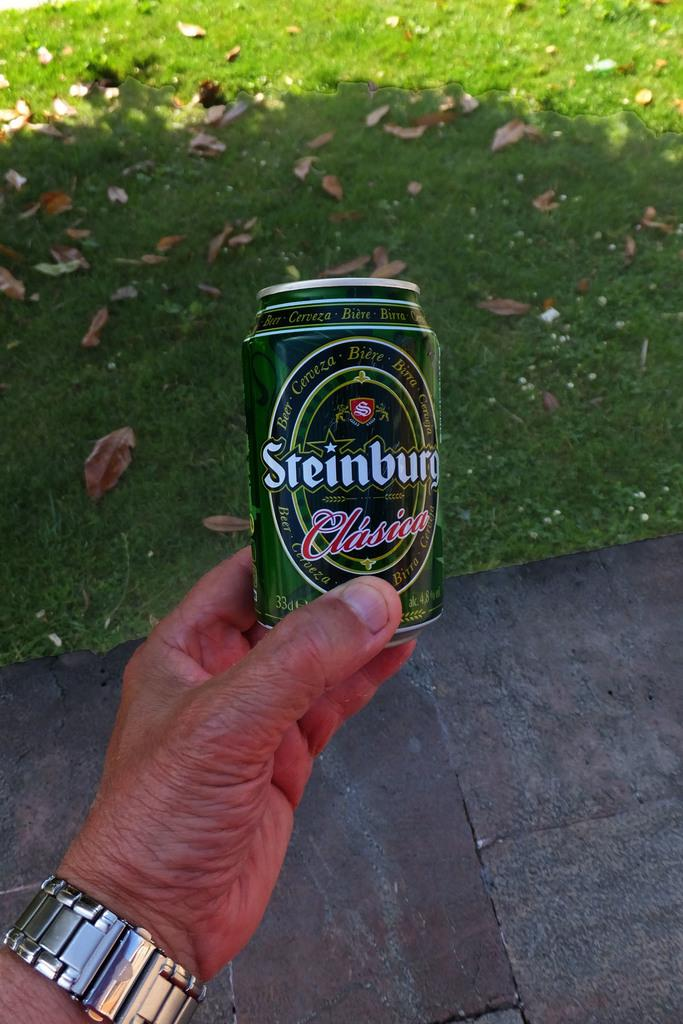<image>
Relay a brief, clear account of the picture shown. A hand holds a green "Steinburg" beer can. 